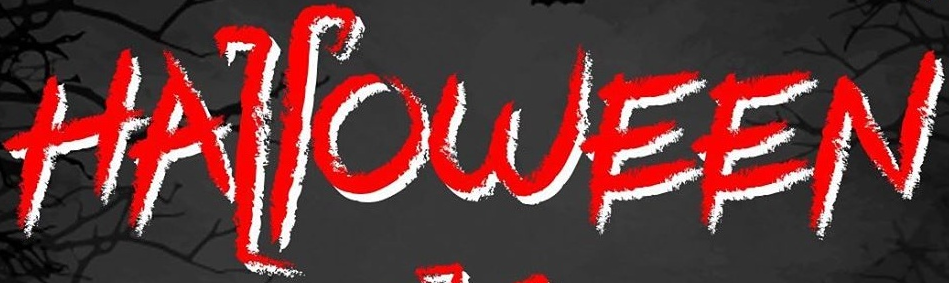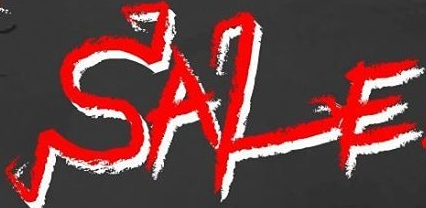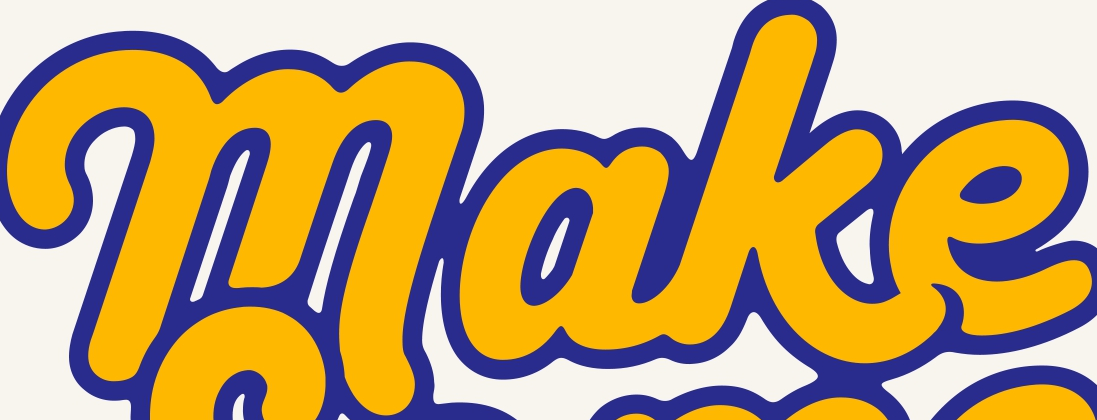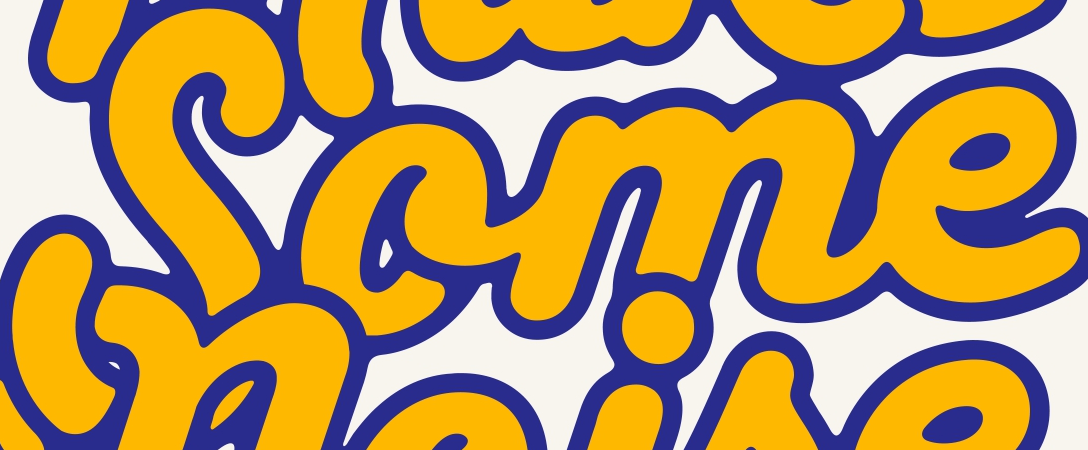What text appears in these images from left to right, separated by a semicolon? HALLOWEEN; SALE; make; Some 